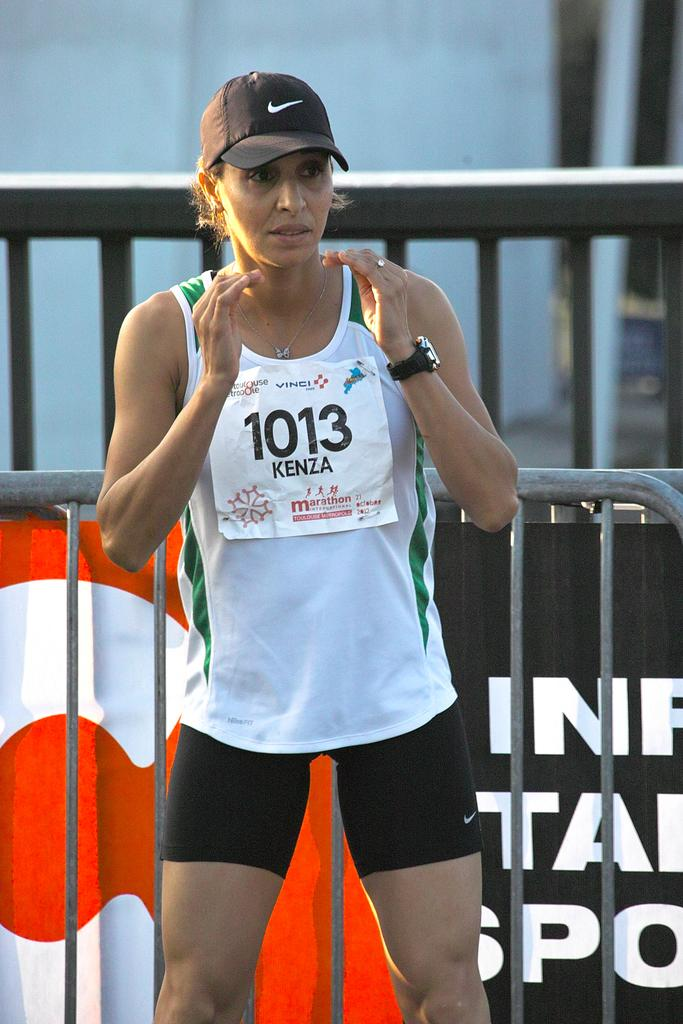<image>
Offer a succinct explanation of the picture presented. Runner #1013 Kenza of marathon International waits on the sidelines. 